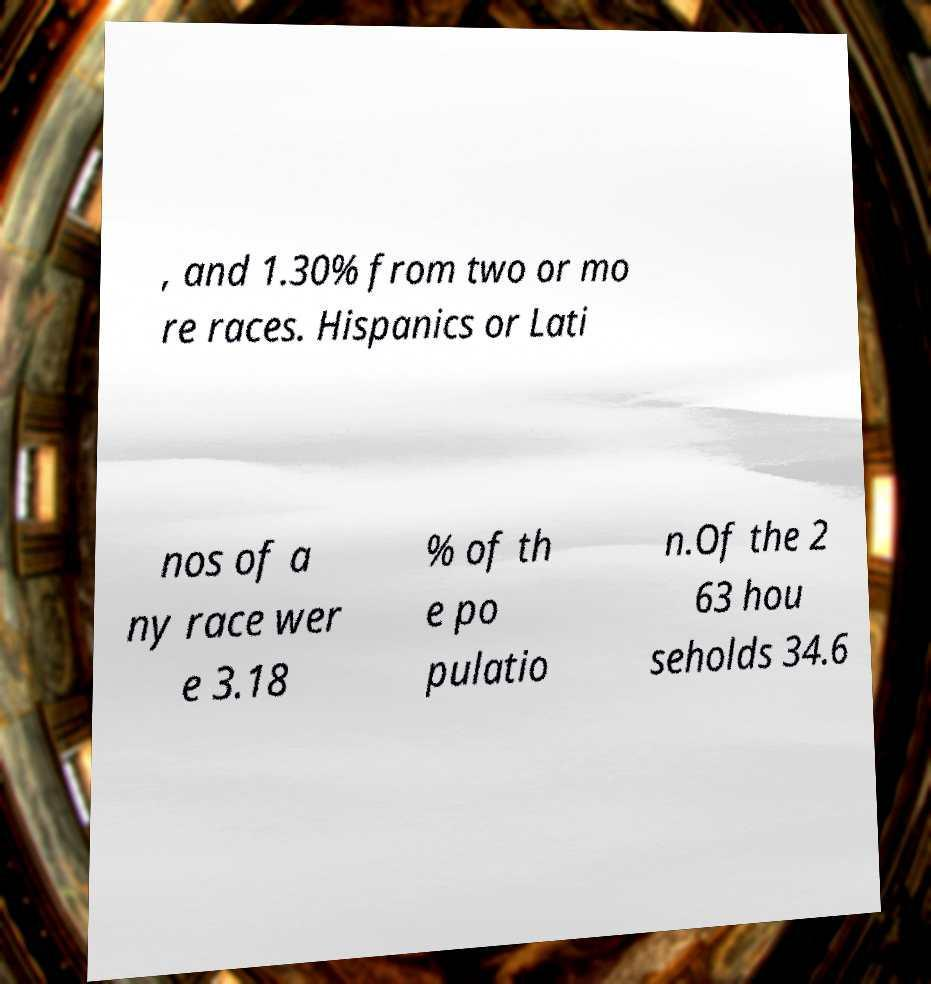Can you accurately transcribe the text from the provided image for me? , and 1.30% from two or mo re races. Hispanics or Lati nos of a ny race wer e 3.18 % of th e po pulatio n.Of the 2 63 hou seholds 34.6 